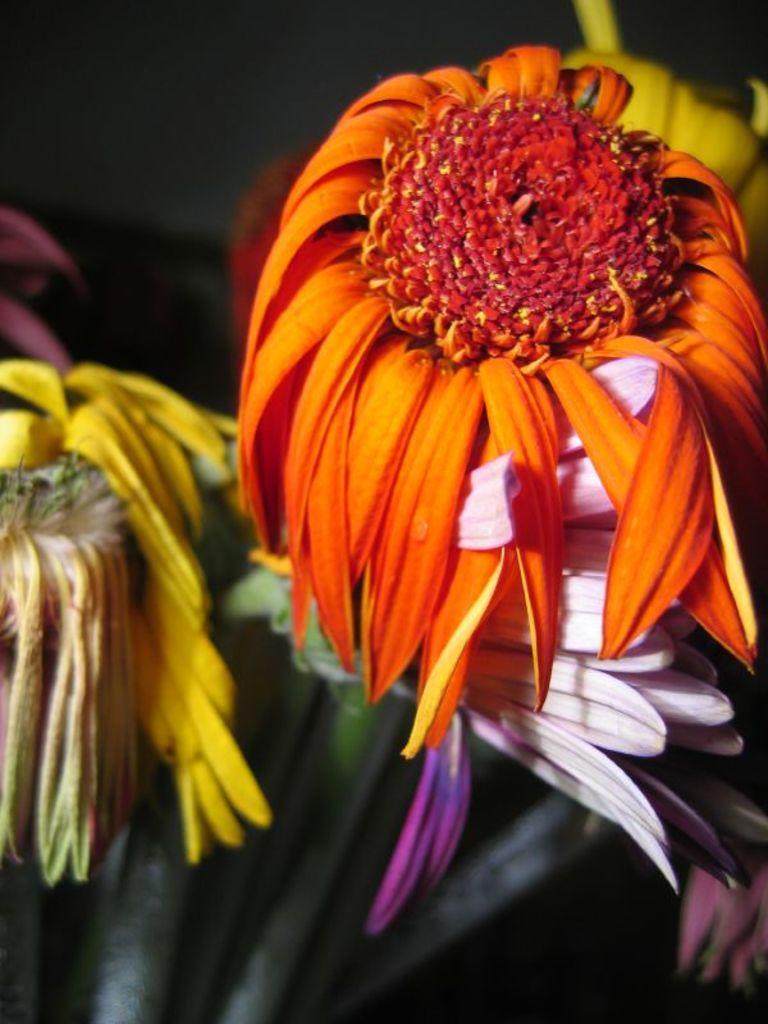How would you summarize this image in a sentence or two? In this image I can see the flowers to the plants. These flowers are in yellow, pink, white and orange color. And there is a black background. 